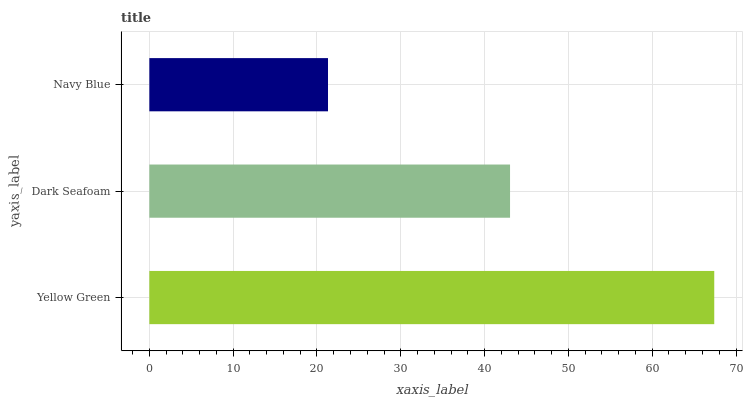Is Navy Blue the minimum?
Answer yes or no. Yes. Is Yellow Green the maximum?
Answer yes or no. Yes. Is Dark Seafoam the minimum?
Answer yes or no. No. Is Dark Seafoam the maximum?
Answer yes or no. No. Is Yellow Green greater than Dark Seafoam?
Answer yes or no. Yes. Is Dark Seafoam less than Yellow Green?
Answer yes or no. Yes. Is Dark Seafoam greater than Yellow Green?
Answer yes or no. No. Is Yellow Green less than Dark Seafoam?
Answer yes or no. No. Is Dark Seafoam the high median?
Answer yes or no. Yes. Is Dark Seafoam the low median?
Answer yes or no. Yes. Is Yellow Green the high median?
Answer yes or no. No. Is Yellow Green the low median?
Answer yes or no. No. 